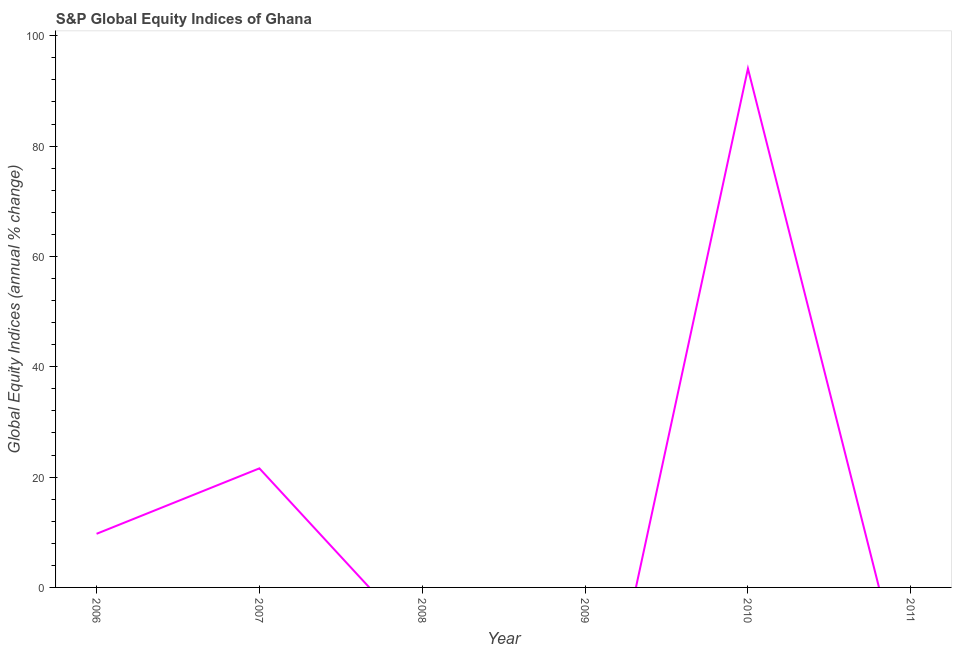What is the s&p global equity indices in 2006?
Your answer should be very brief. 9.72. Across all years, what is the maximum s&p global equity indices?
Keep it short and to the point. 94.06. Across all years, what is the minimum s&p global equity indices?
Offer a terse response. 0. What is the sum of the s&p global equity indices?
Your answer should be compact. 125.37. What is the difference between the s&p global equity indices in 2007 and 2010?
Your response must be concise. -72.48. What is the average s&p global equity indices per year?
Provide a succinct answer. 20.89. What is the median s&p global equity indices?
Make the answer very short. 4.86. What is the ratio of the s&p global equity indices in 2006 to that in 2010?
Your answer should be compact. 0.1. What is the difference between the highest and the second highest s&p global equity indices?
Your response must be concise. 72.48. What is the difference between the highest and the lowest s&p global equity indices?
Provide a short and direct response. 94.06. In how many years, is the s&p global equity indices greater than the average s&p global equity indices taken over all years?
Your response must be concise. 2. Does the s&p global equity indices monotonically increase over the years?
Offer a terse response. No. How many years are there in the graph?
Your answer should be very brief. 6. What is the title of the graph?
Offer a very short reply. S&P Global Equity Indices of Ghana. What is the label or title of the X-axis?
Provide a short and direct response. Year. What is the label or title of the Y-axis?
Your answer should be very brief. Global Equity Indices (annual % change). What is the Global Equity Indices (annual % change) in 2006?
Your answer should be compact. 9.72. What is the Global Equity Indices (annual % change) in 2007?
Provide a succinct answer. 21.58. What is the Global Equity Indices (annual % change) in 2008?
Provide a short and direct response. 0. What is the Global Equity Indices (annual % change) of 2009?
Your answer should be very brief. 0. What is the Global Equity Indices (annual % change) of 2010?
Your response must be concise. 94.06. What is the Global Equity Indices (annual % change) of 2011?
Make the answer very short. 0. What is the difference between the Global Equity Indices (annual % change) in 2006 and 2007?
Make the answer very short. -11.86. What is the difference between the Global Equity Indices (annual % change) in 2006 and 2010?
Your response must be concise. -84.34. What is the difference between the Global Equity Indices (annual % change) in 2007 and 2010?
Your response must be concise. -72.48. What is the ratio of the Global Equity Indices (annual % change) in 2006 to that in 2007?
Provide a short and direct response. 0.45. What is the ratio of the Global Equity Indices (annual % change) in 2006 to that in 2010?
Offer a very short reply. 0.1. What is the ratio of the Global Equity Indices (annual % change) in 2007 to that in 2010?
Your answer should be very brief. 0.23. 